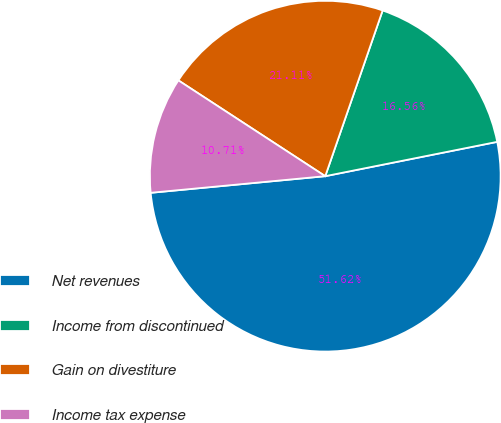Convert chart. <chart><loc_0><loc_0><loc_500><loc_500><pie_chart><fcel>Net revenues<fcel>Income from discontinued<fcel>Gain on divestiture<fcel>Income tax expense<nl><fcel>51.63%<fcel>16.56%<fcel>21.11%<fcel>10.71%<nl></chart> 